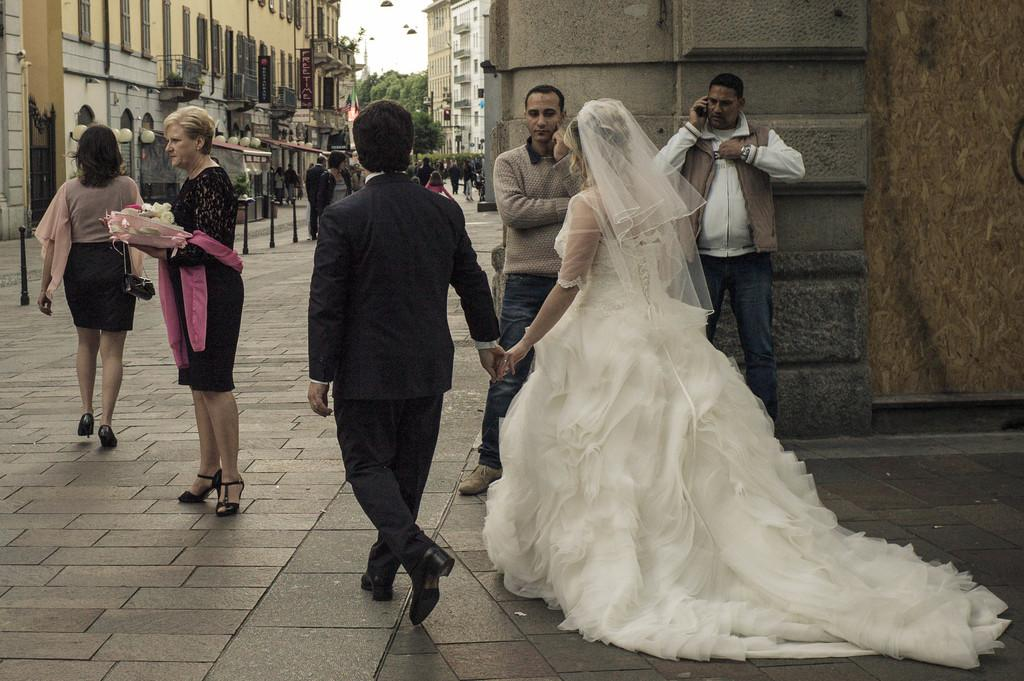How many persons are in the image? There are persons in the image. What type of natural elements can be seen in the image? There are trees in the image. What type of man-made structures are present in the image? There are poles, a traffic signal, lights, boards, and buildings in the image. What is visible in the background of the image? The sky is visible in the background of the image. What type of nut is being cracked by the person in the image? There is no nut present in the image, and no person is shown cracking a nut. What is the person in the image afraid of? There is no indication of fear or any specific object of fear in the image. 